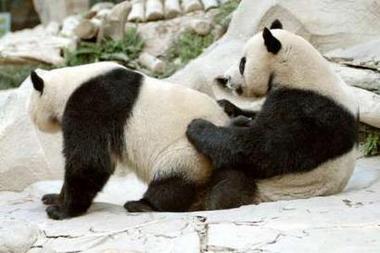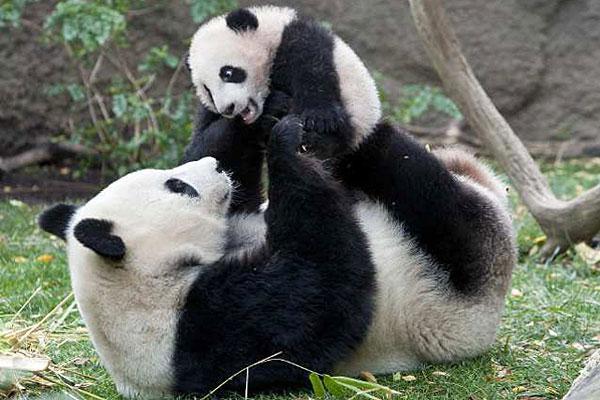The first image is the image on the left, the second image is the image on the right. Considering the images on both sides, is "There is a total of three pandas." valid? Answer yes or no. No. The first image is the image on the left, the second image is the image on the right. Evaluate the accuracy of this statement regarding the images: "Two pandas are playing together in each of the images.". Is it true? Answer yes or no. Yes. 